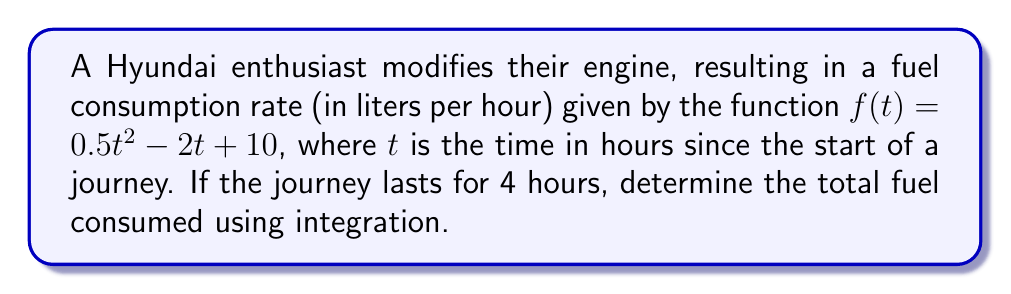Provide a solution to this math problem. To find the total fuel consumed over the 4-hour journey, we need to integrate the fuel consumption rate function from $t=0$ to $t=4$. Here's how we do it:

1) Set up the definite integral:
   $$\int_0^4 (0.5t^2 - 2t + 10) dt$$

2) Integrate the function:
   $$\left[\frac{1}{6}t^3 - t^2 + 10t\right]_0^4$$

3) Evaluate the integral:
   $$\left(\frac{1}{6}(4^3) - 4^2 + 10(4)\right) - \left(\frac{1}{6}(0^3) - 0^2 + 10(0)\right)$$

4) Simplify:
   $$\left(\frac{64}{6} - 16 + 40\right) - (0)$$
   $$= \frac{64}{6} + 24$$
   $$= \frac{64 + 144}{6}$$
   $$= \frac{208}{6}$$
   $$= \frac{104}{3}$$

Therefore, the total fuel consumed over the 4-hour journey is $\frac{104}{3}$ liters.
Answer: $\frac{104}{3}$ liters 